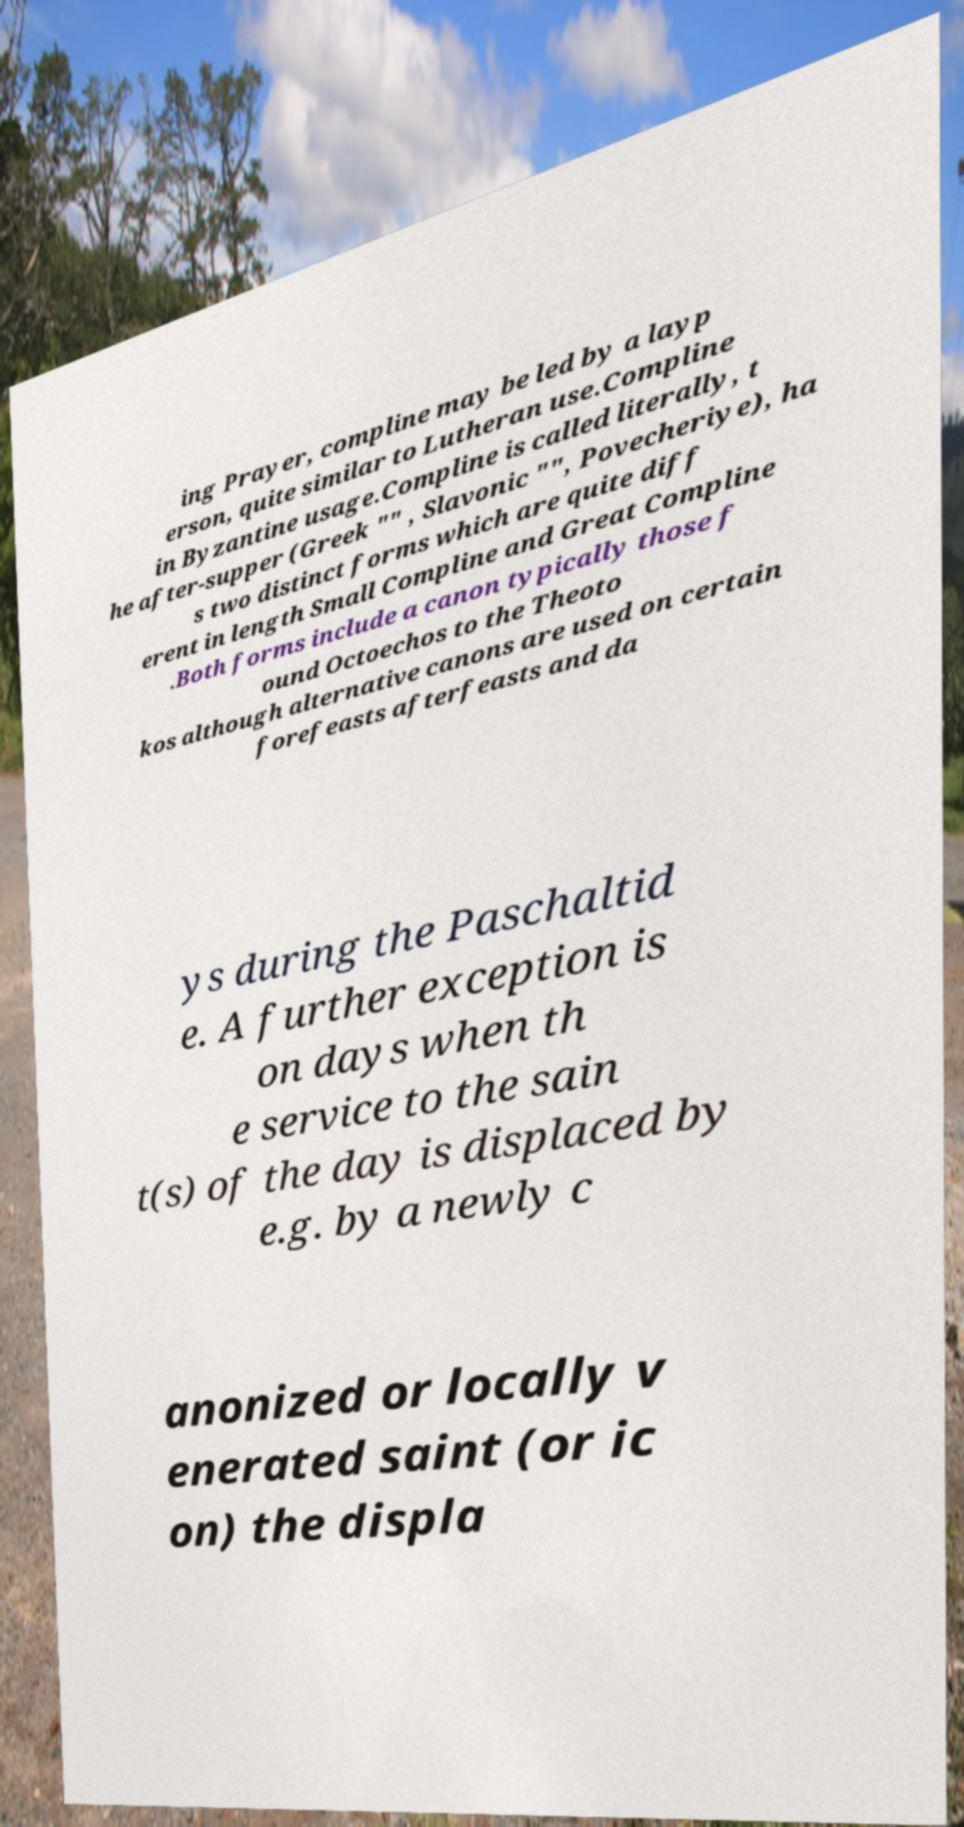There's text embedded in this image that I need extracted. Can you transcribe it verbatim? ing Prayer, compline may be led by a layp erson, quite similar to Lutheran use.Compline in Byzantine usage.Compline is called literally, t he after-supper (Greek "" , Slavonic "", Povecheriye), ha s two distinct forms which are quite diff erent in length Small Compline and Great Compline .Both forms include a canon typically those f ound Octoechos to the Theoto kos although alternative canons are used on certain forefeasts afterfeasts and da ys during the Paschaltid e. A further exception is on days when th e service to the sain t(s) of the day is displaced by e.g. by a newly c anonized or locally v enerated saint (or ic on) the displa 